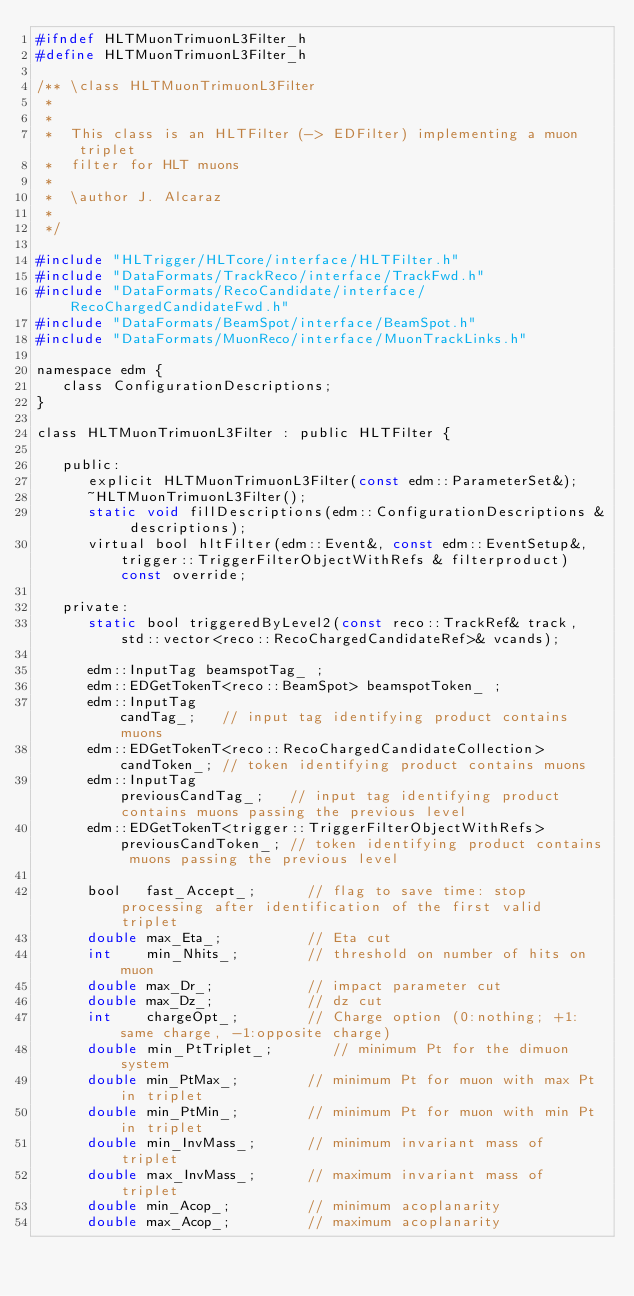Convert code to text. <code><loc_0><loc_0><loc_500><loc_500><_C_>#ifndef HLTMuonTrimuonL3Filter_h
#define HLTMuonTrimuonL3Filter_h

/** \class HLTMuonTrimuonL3Filter
 *
 *
 *  This class is an HLTFilter (-> EDFilter) implementing a muon triplet
 *  filter for HLT muons
 *
 *  \author J. Alcaraz
 *
 */

#include "HLTrigger/HLTcore/interface/HLTFilter.h"
#include "DataFormats/TrackReco/interface/TrackFwd.h"
#include "DataFormats/RecoCandidate/interface/RecoChargedCandidateFwd.h"
#include "DataFormats/BeamSpot/interface/BeamSpot.h"
#include "DataFormats/MuonReco/interface/MuonTrackLinks.h"

namespace edm {
   class ConfigurationDescriptions;
}

class HLTMuonTrimuonL3Filter : public HLTFilter {

   public:
      explicit HLTMuonTrimuonL3Filter(const edm::ParameterSet&);
      ~HLTMuonTrimuonL3Filter();
      static void fillDescriptions(edm::ConfigurationDescriptions & descriptions);
      virtual bool hltFilter(edm::Event&, const edm::EventSetup&, trigger::TriggerFilterObjectWithRefs & filterproduct) const override;

   private:
      static bool triggeredByLevel2(const reco::TrackRef& track, std::vector<reco::RecoChargedCandidateRef>& vcands);

      edm::InputTag beamspotTag_ ;
      edm::EDGetTokenT<reco::BeamSpot> beamspotToken_ ;
      edm::InputTag                                          candTag_;   // input tag identifying product contains muons
      edm::EDGetTokenT<reco::RecoChargedCandidateCollection> candToken_; // token identifying product contains muons
      edm::InputTag                                          previousCandTag_;   // input tag identifying product contains muons passing the previous level
      edm::EDGetTokenT<trigger::TriggerFilterObjectWithRefs> previousCandToken_; // token identifying product contains muons passing the previous level

      bool   fast_Accept_;      // flag to save time: stop processing after identification of the first valid triplet
      double max_Eta_;          // Eta cut
      int    min_Nhits_;        // threshold on number of hits on muon
      double max_Dr_;           // impact parameter cut
      double max_Dz_;           // dz cut
      int    chargeOpt_;        // Charge option (0:nothing; +1:same charge, -1:opposite charge)
      double min_PtTriplet_;       // minimum Pt for the dimuon system
      double min_PtMax_;        // minimum Pt for muon with max Pt in triplet
      double min_PtMin_;        // minimum Pt for muon with min Pt in triplet
      double min_InvMass_;      // minimum invariant mass of triplet
      double max_InvMass_;      // maximum invariant mass of triplet
      double min_Acop_;         // minimum acoplanarity
      double max_Acop_;         // maximum acoplanarity</code> 